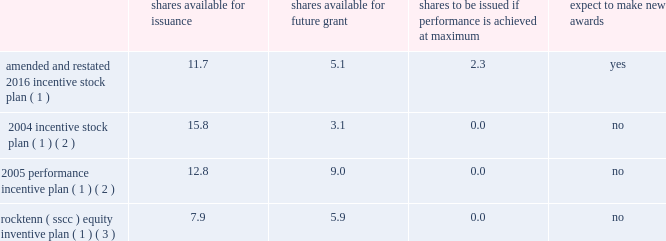Westrock company notes to consolidated financial statements 2014 ( continued ) note 20 .
Stockholders 2019 equity capitalization our capital stock consists solely of common stock .
Holders of our common stock are entitled to one vote per share .
Our amended and restated certificate of incorporation also authorizes preferred stock , of which no shares have been issued .
The terms and provisions of such shares will be determined by our board of directors upon any issuance of such shares in accordance with our certificate of incorporation .
Stock repurchase plan in july 2015 , our board of directors authorized a repurchase program of up to 40.0 million shares of our common stock , representing approximately 15% ( 15 % ) of our outstanding common stock as of july 1 , 2015 .
The shares of our common stock may be repurchased over an indefinite period of time at the discretion of management .
In fiscal 2019 , we repurchased approximately 2.1 million shares of our common stock for an aggregate cost of $ 88.6 million .
In fiscal 2018 , we repurchased approximately 3.4 million shares of our common stock for an aggregate cost of $ 195.1 million .
In fiscal 2017 , we repurchased approximately 1.8 million shares of our common stock for an aggregate cost of $ 93.0 million .
As of september 30 , 2019 , we had remaining authorization under the repurchase program authorized in july 2015 to purchase approximately 19.1 million shares of our common stock .
Note 21 .
Share-based compensation share-based compensation plans at our annual meeting of stockholders held on february 2 , 2016 , our stockholders approved the westrock company 2016 incentive stock plan .
The 2016 incentive stock plan was amended and restated on february 2 , 2018 ( the 201camended and restated 2016 incentive stock plan 201d ) .
The amended and restated 2016 incentive stock plan allows for the granting of options , restricted stock , sars and restricted stock units to certain key employees and directors .
The table below shows the approximate number of shares : available for issuance , available for future grant , to be issued if restricted awards granted with a performance condition recorded at target achieve the maximum award , and if new grants pursuant to the plan are expected to be issued , each as adjusted as necessary for corporate actions ( in millions ) .
Shares available issuance shares available for future shares to be issued if performance is achieved at maximum expect to awards amended and restated 2016 incentive stock plan ( 1 ) 11.7 5.1 2.3 yes 2004 incentive stock plan ( 1 ) ( 2 ) 15.8 3.1 0.0 no 2005 performance incentive plan ( 1 ) ( 2 ) 12.8 9.0 0.0 no rocktenn ( sscc ) equity inventive plan ( 1 ) ( 3 ) 7.9 5.9 0.0 no ( 1 ) as part of the separation , equity-based incentive awards were generally adjusted to maintain the intrinsic value of awards immediately prior to the separation .
The number of unvested restricted stock awards and unexercised stock options and sars at the time of the separation were increased by an exchange factor of approximately 1.12 .
In addition , the exercise price of unexercised stock options and sars at the time of the separation was converted to decrease the exercise price by an exchange factor of approximately 1.12 .
( 2 ) in connection with the combination , westrock assumed all rocktenn and mwv equity incentive plans .
We issued awards to certain key employees and our directors pursuant to our rocktenn 2004 incentive stock plan , as amended , and our mwv 2005 performance incentive plan , as amended .
The awards were converted into westrock awards using the conversion factor as described in the business combination agreement .
( 3 ) in connection with the smurfit-stone acquisition , we assumed the smurfit-stone equity incentive plan , which was renamed the rock-tenn company ( sscc ) equity incentive plan .
The awards were converted into shares of rocktenn common stock , options and restricted stock units , as applicable , using the conversion factor as described in the merger agreement. .
Westrock company notes to consolidated financial statements 2014 ( continued ) note 20 .
Stockholders 2019 equity capitalization our capital stock consists solely of common stock .
Holders of our common stock are entitled to one vote per share .
Our amended and restated certificate of incorporation also authorizes preferred stock , of which no shares have been issued .
The terms and provisions of such shares will be determined by our board of directors upon any issuance of such shares in accordance with our certificate of incorporation .
Stock repurchase plan in july 2015 , our board of directors authorized a repurchase program of up to 40.0 million shares of our common stock , representing approximately 15% ( 15 % ) of our outstanding common stock as of july 1 , 2015 .
The shares of our common stock may be repurchased over an indefinite period of time at the discretion of management .
In fiscal 2019 , we repurchased approximately 2.1 million shares of our common stock for an aggregate cost of $ 88.6 million .
In fiscal 2018 , we repurchased approximately 3.4 million shares of our common stock for an aggregate cost of $ 195.1 million .
In fiscal 2017 , we repurchased approximately 1.8 million shares of our common stock for an aggregate cost of $ 93.0 million .
As of september 30 , 2019 , we had remaining authorization under the repurchase program authorized in july 2015 to purchase approximately 19.1 million shares of our common stock .
Note 21 .
Share-based compensation share-based compensation plans at our annual meeting of stockholders held on february 2 , 2016 , our stockholders approved the westrock company 2016 incentive stock plan .
The 2016 incentive stock plan was amended and restated on february 2 , 2018 ( the 201camended and restated 2016 incentive stock plan 201d ) .
The amended and restated 2016 incentive stock plan allows for the granting of options , restricted stock , sars and restricted stock units to certain key employees and directors .
The table below shows the approximate number of shares : available for issuance , available for future grant , to be issued if restricted awards granted with a performance condition recorded at target achieve the maximum award , and if new grants pursuant to the plan are expected to be issued , each as adjusted as necessary for corporate actions ( in millions ) .
Shares available issuance shares available for future shares to be issued if performance is achieved at maximum expect to awards amended and restated 2016 incentive stock plan ( 1 ) 11.7 5.1 2.3 yes 2004 incentive stock plan ( 1 ) ( 2 ) 15.8 3.1 0.0 no 2005 performance incentive plan ( 1 ) ( 2 ) 12.8 9.0 0.0 no rocktenn ( sscc ) equity inventive plan ( 1 ) ( 3 ) 7.9 5.9 0.0 no ( 1 ) as part of the separation , equity-based incentive awards were generally adjusted to maintain the intrinsic value of awards immediately prior to the separation .
The number of unvested restricted stock awards and unexercised stock options and sars at the time of the separation were increased by an exchange factor of approximately 1.12 .
In addition , the exercise price of unexercised stock options and sars at the time of the separation was converted to decrease the exercise price by an exchange factor of approximately 1.12 .
( 2 ) in connection with the combination , westrock assumed all rocktenn and mwv equity incentive plans .
We issued awards to certain key employees and our directors pursuant to our rocktenn 2004 incentive stock plan , as amended , and our mwv 2005 performance incentive plan , as amended .
The awards were converted into westrock awards using the conversion factor as described in the business combination agreement .
( 3 ) in connection with the smurfit-stone acquisition , we assumed the smurfit-stone equity incentive plan , which was renamed the rock-tenn company ( sscc ) equity incentive plan .
The awards were converted into shares of rocktenn common stock , options and restricted stock units , as applicable , using the conversion factor as described in the merger agreement. .
What was the average stock price in 2019? ( $ )? 
Computations: (88.6 / 2.1)
Answer: 42.19048. 